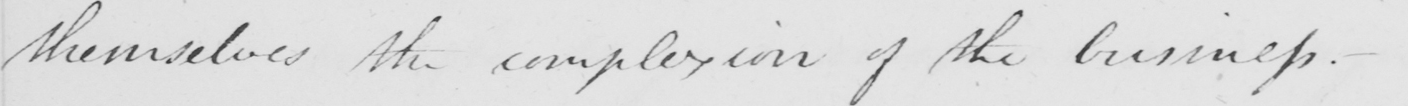Please transcribe the handwritten text in this image. themselves the complexion of the business . 